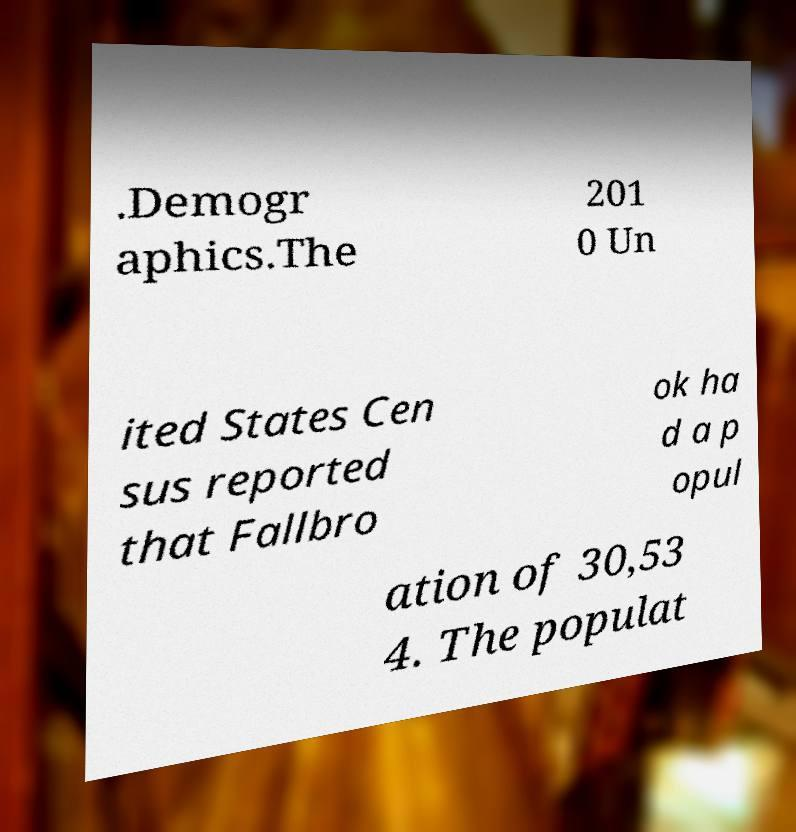Can you accurately transcribe the text from the provided image for me? .Demogr aphics.The 201 0 Un ited States Cen sus reported that Fallbro ok ha d a p opul ation of 30,53 4. The populat 